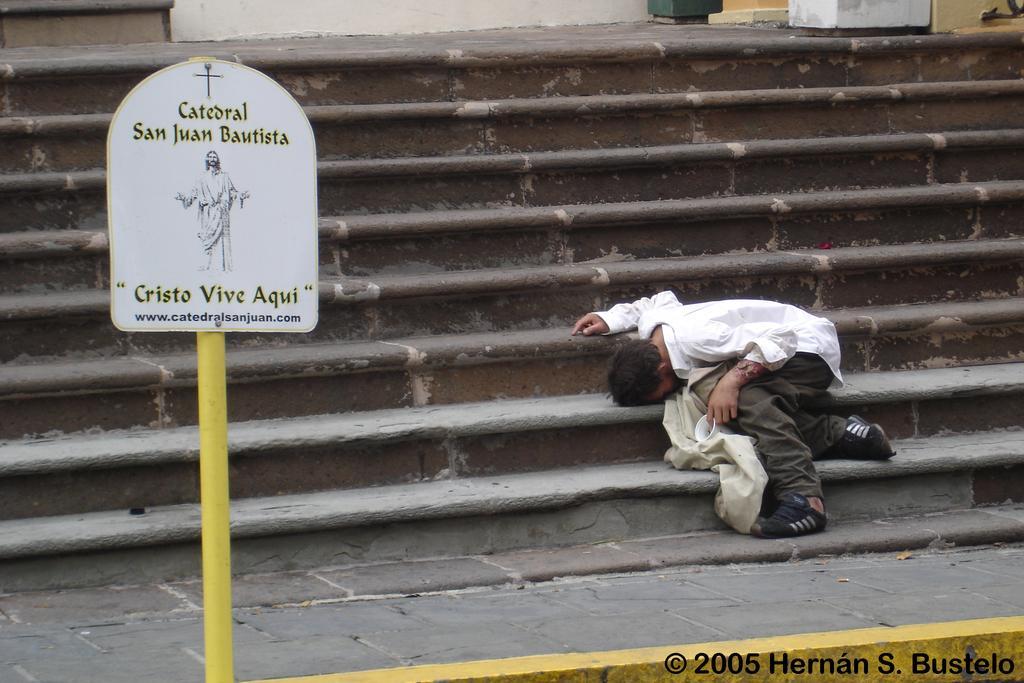Can you describe this image briefly? In this image I can see a person sitting on the staircases, in front there is a board to the pole. 